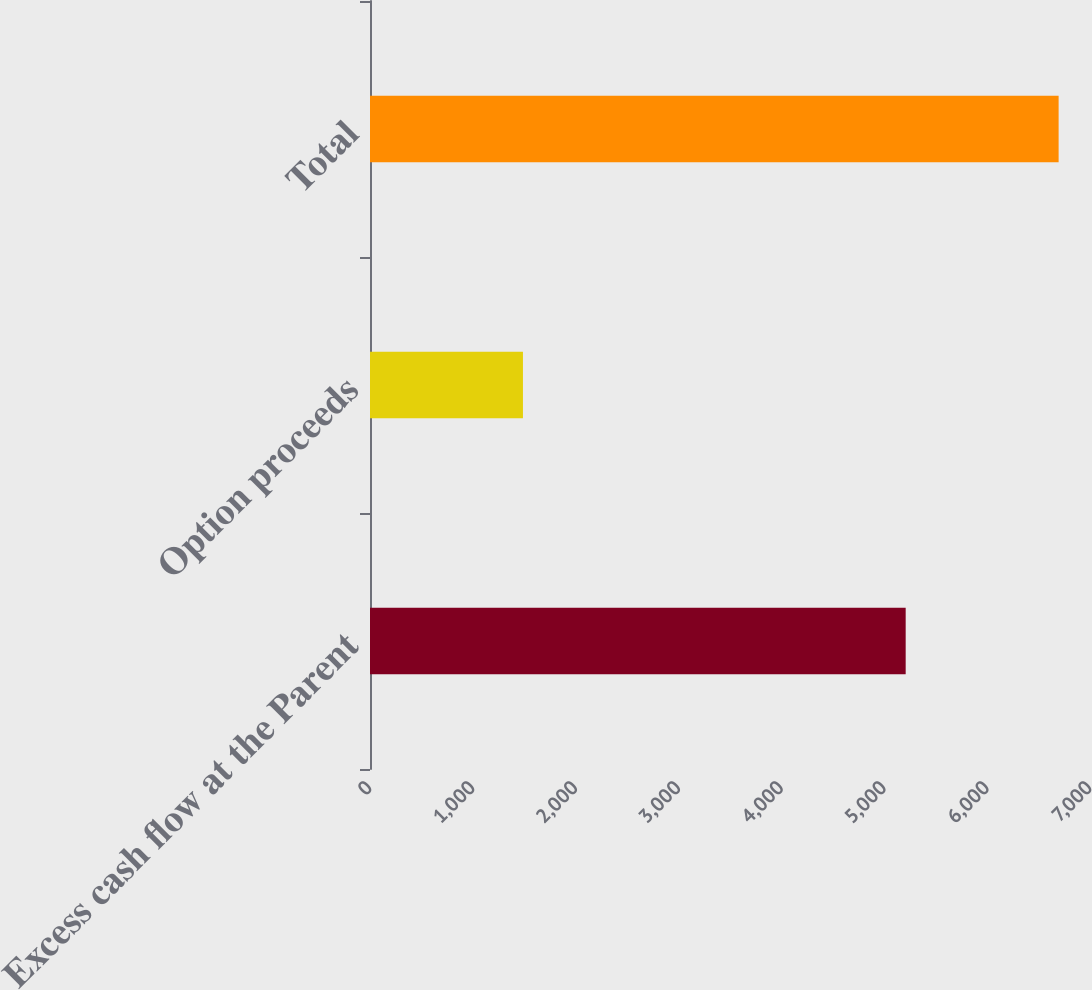<chart> <loc_0><loc_0><loc_500><loc_500><bar_chart><fcel>Excess cash flow at the Parent<fcel>Option proceeds<fcel>Total<nl><fcel>5208<fcel>1487<fcel>6695<nl></chart> 